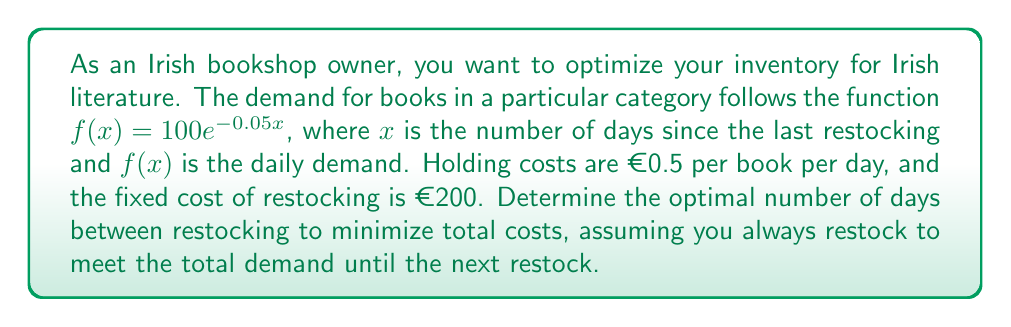Help me with this question. To solve this problem, we'll use the Economic Order Quantity (EOQ) model adapted for continuous demand. Let's break it down step-by-step:

1) First, we need to find the total demand over a period $T$ days. This is given by the integral of the demand function:

   $$Q(T) = \int_0^T 100e^{-0.05x} dx$$

2) Evaluating this integral:
   
   $$Q(T) = -2000e^{-0.05x}|_0^T = -2000(e^{-0.05T} - 1)$$

3) The total cost function consists of holding costs and ordering costs:

   $$TC(T) = \frac{h}{2T}[Q(T)]^2 + \frac{K}{T}Q(T)$$

   Where $h$ is the holding cost per book per day (€0.5) and $K$ is the fixed cost of restocking (€200).

4) Substituting our $Q(T)$ and the given values:

   $$TC(T) = \frac{0.5}{2T}[2000(1-e^{-0.05T})]^2 + \frac{200}{T}[2000(1-e^{-0.05T})]$$

5) To find the minimum, we differentiate $TC(T)$ with respect to $T$ and set it to zero:

   $$\frac{d}{dT}TC(T) = 0$$

6) This results in a complex equation that can't be solved analytically. We need to use numerical methods to find the optimal $T$.

7) Using a numerical solver (like Newton-Raphson method), we find that the optimal $T$ is approximately 14.3 days.
Answer: The optimal time between restocking is approximately 14.3 days. 